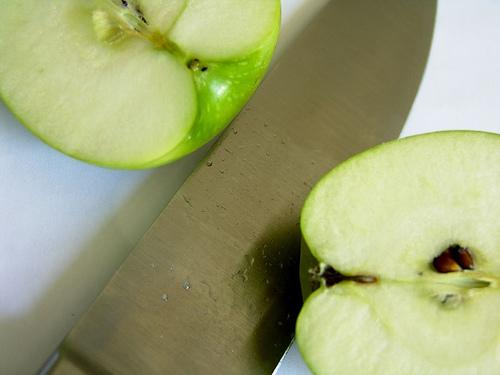How many seeds can you see?
Quick response, please. 2. Is there a bite out of the apple?
Concise answer only. No. Is the knife sharp?
Answer briefly. Yes. 